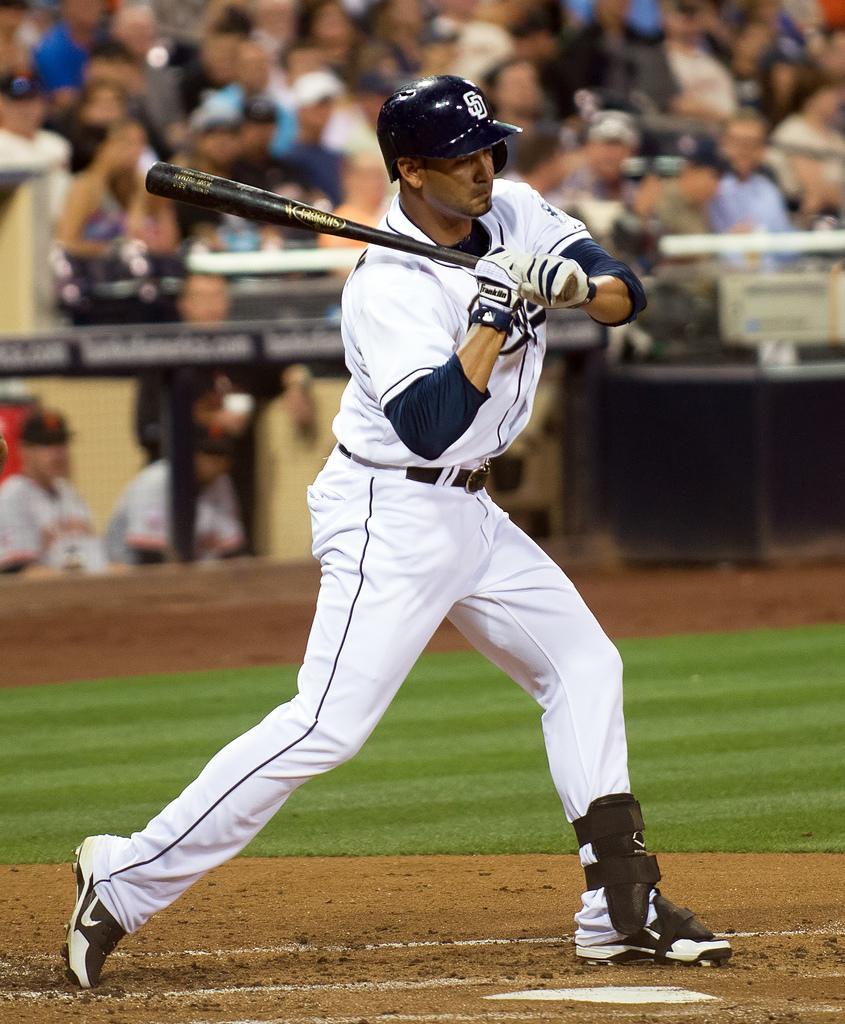How would you summarize this image in a sentence or two? This is a playing ground. Here I can see a man wearing white color dress, standing facing towards the right side and holding a bat in the hands. In the background, I can see a crowd of people and also there is a railing. On the ground, I can see the grass. 